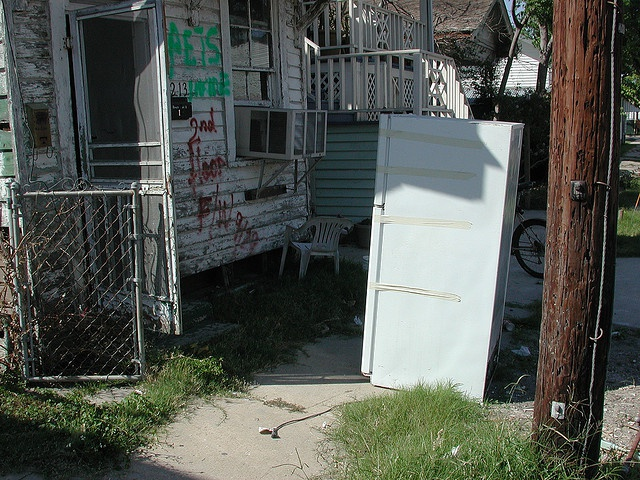Describe the objects in this image and their specific colors. I can see refrigerator in gray and lightgray tones, chair in gray, black, purple, darkblue, and blue tones, and bicycle in gray, black, and darkblue tones in this image. 